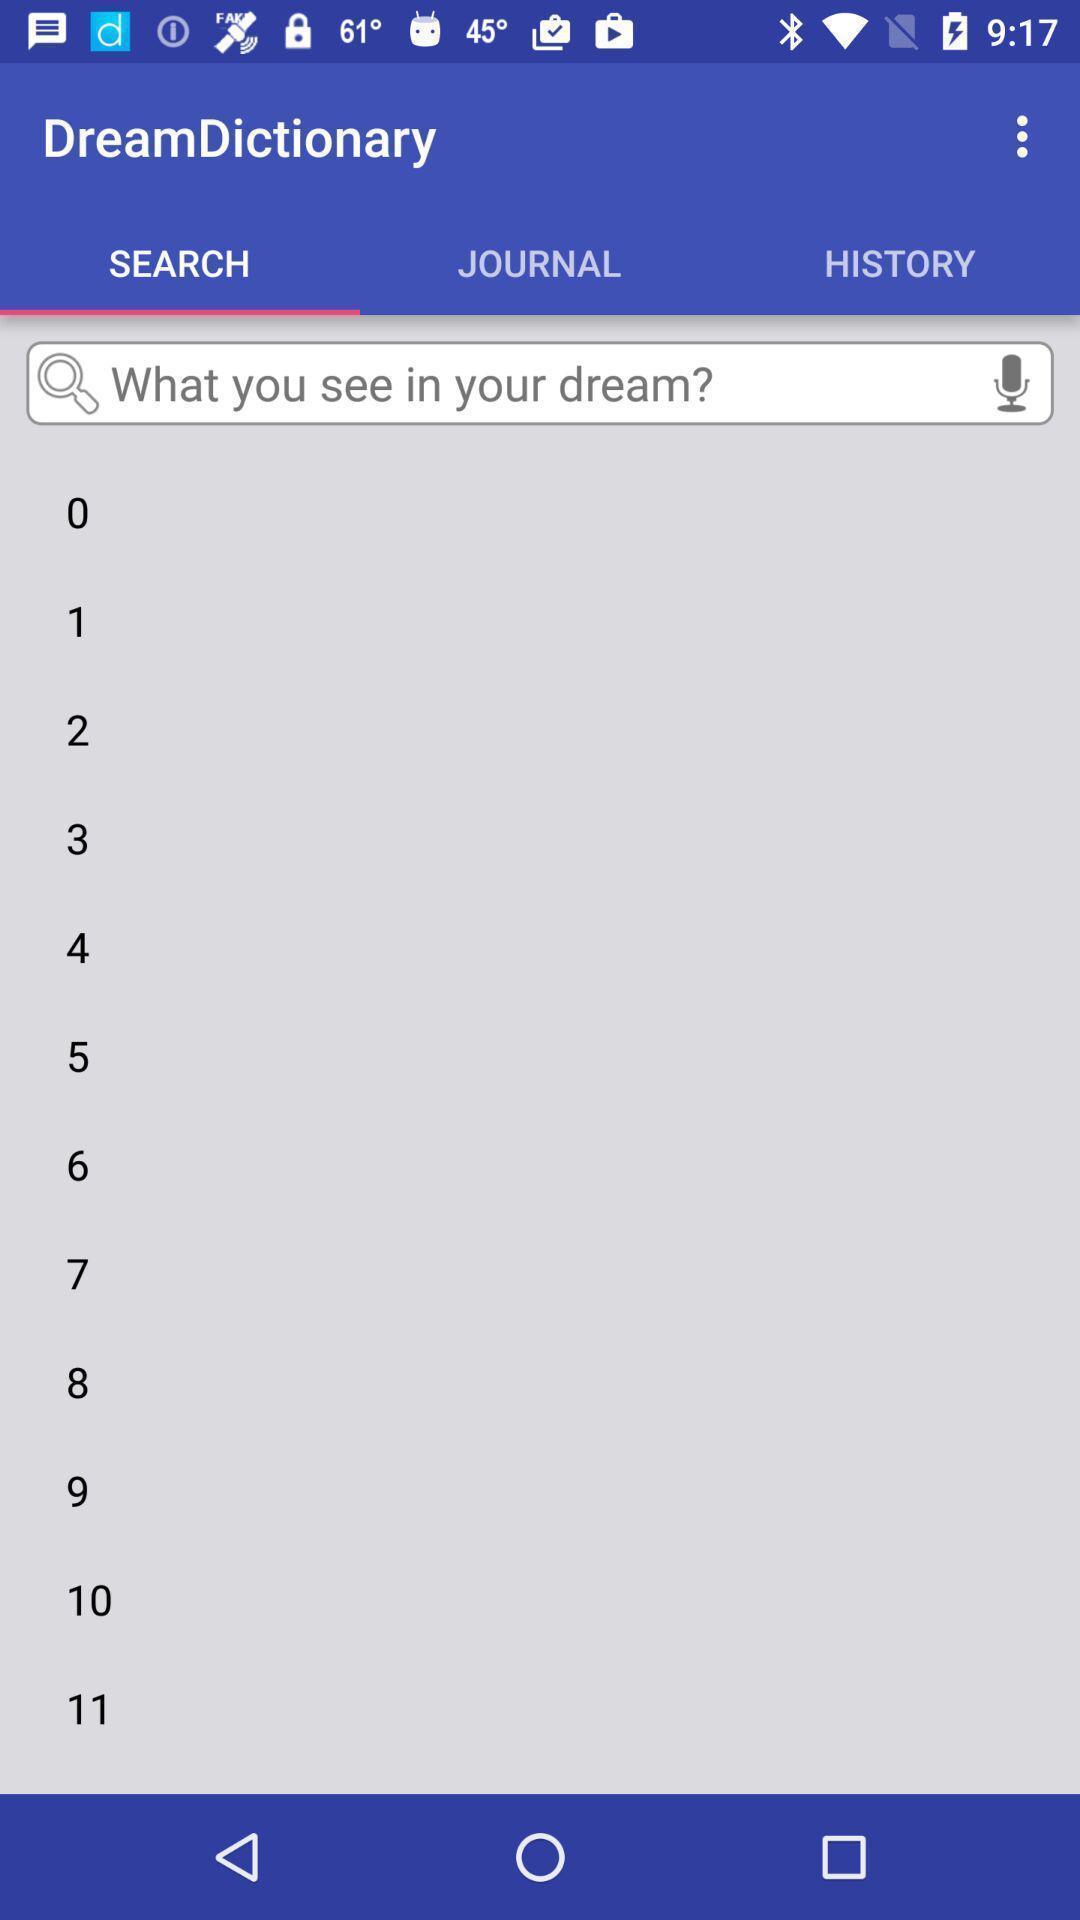Give me a summary of this screen capture. Search page of the dream dictionary. 